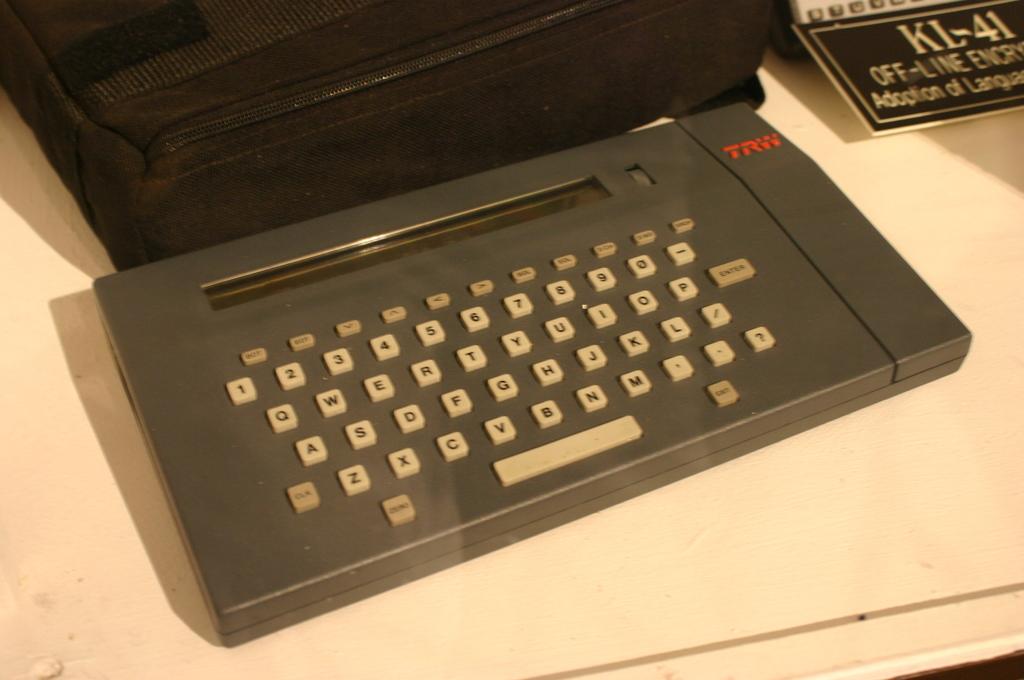What brand is the keyboard?
Your answer should be compact. Trw. What is one of the letters on the keyboard?
Your answer should be very brief. Q. 